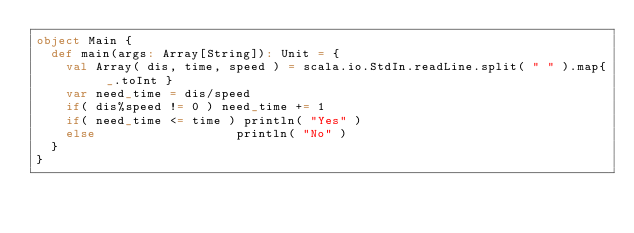<code> <loc_0><loc_0><loc_500><loc_500><_Scala_>object Main {
  def main(args: Array[String]): Unit = {
    val Array( dis, time, speed ) = scala.io.StdIn.readLine.split( " " ).map{ _.toInt }
    var need_time = dis/speed
    if( dis%speed != 0 ) need_time += 1
    if( need_time <= time ) println( "Yes" )
    else                   println( "No" )
  }
}</code> 